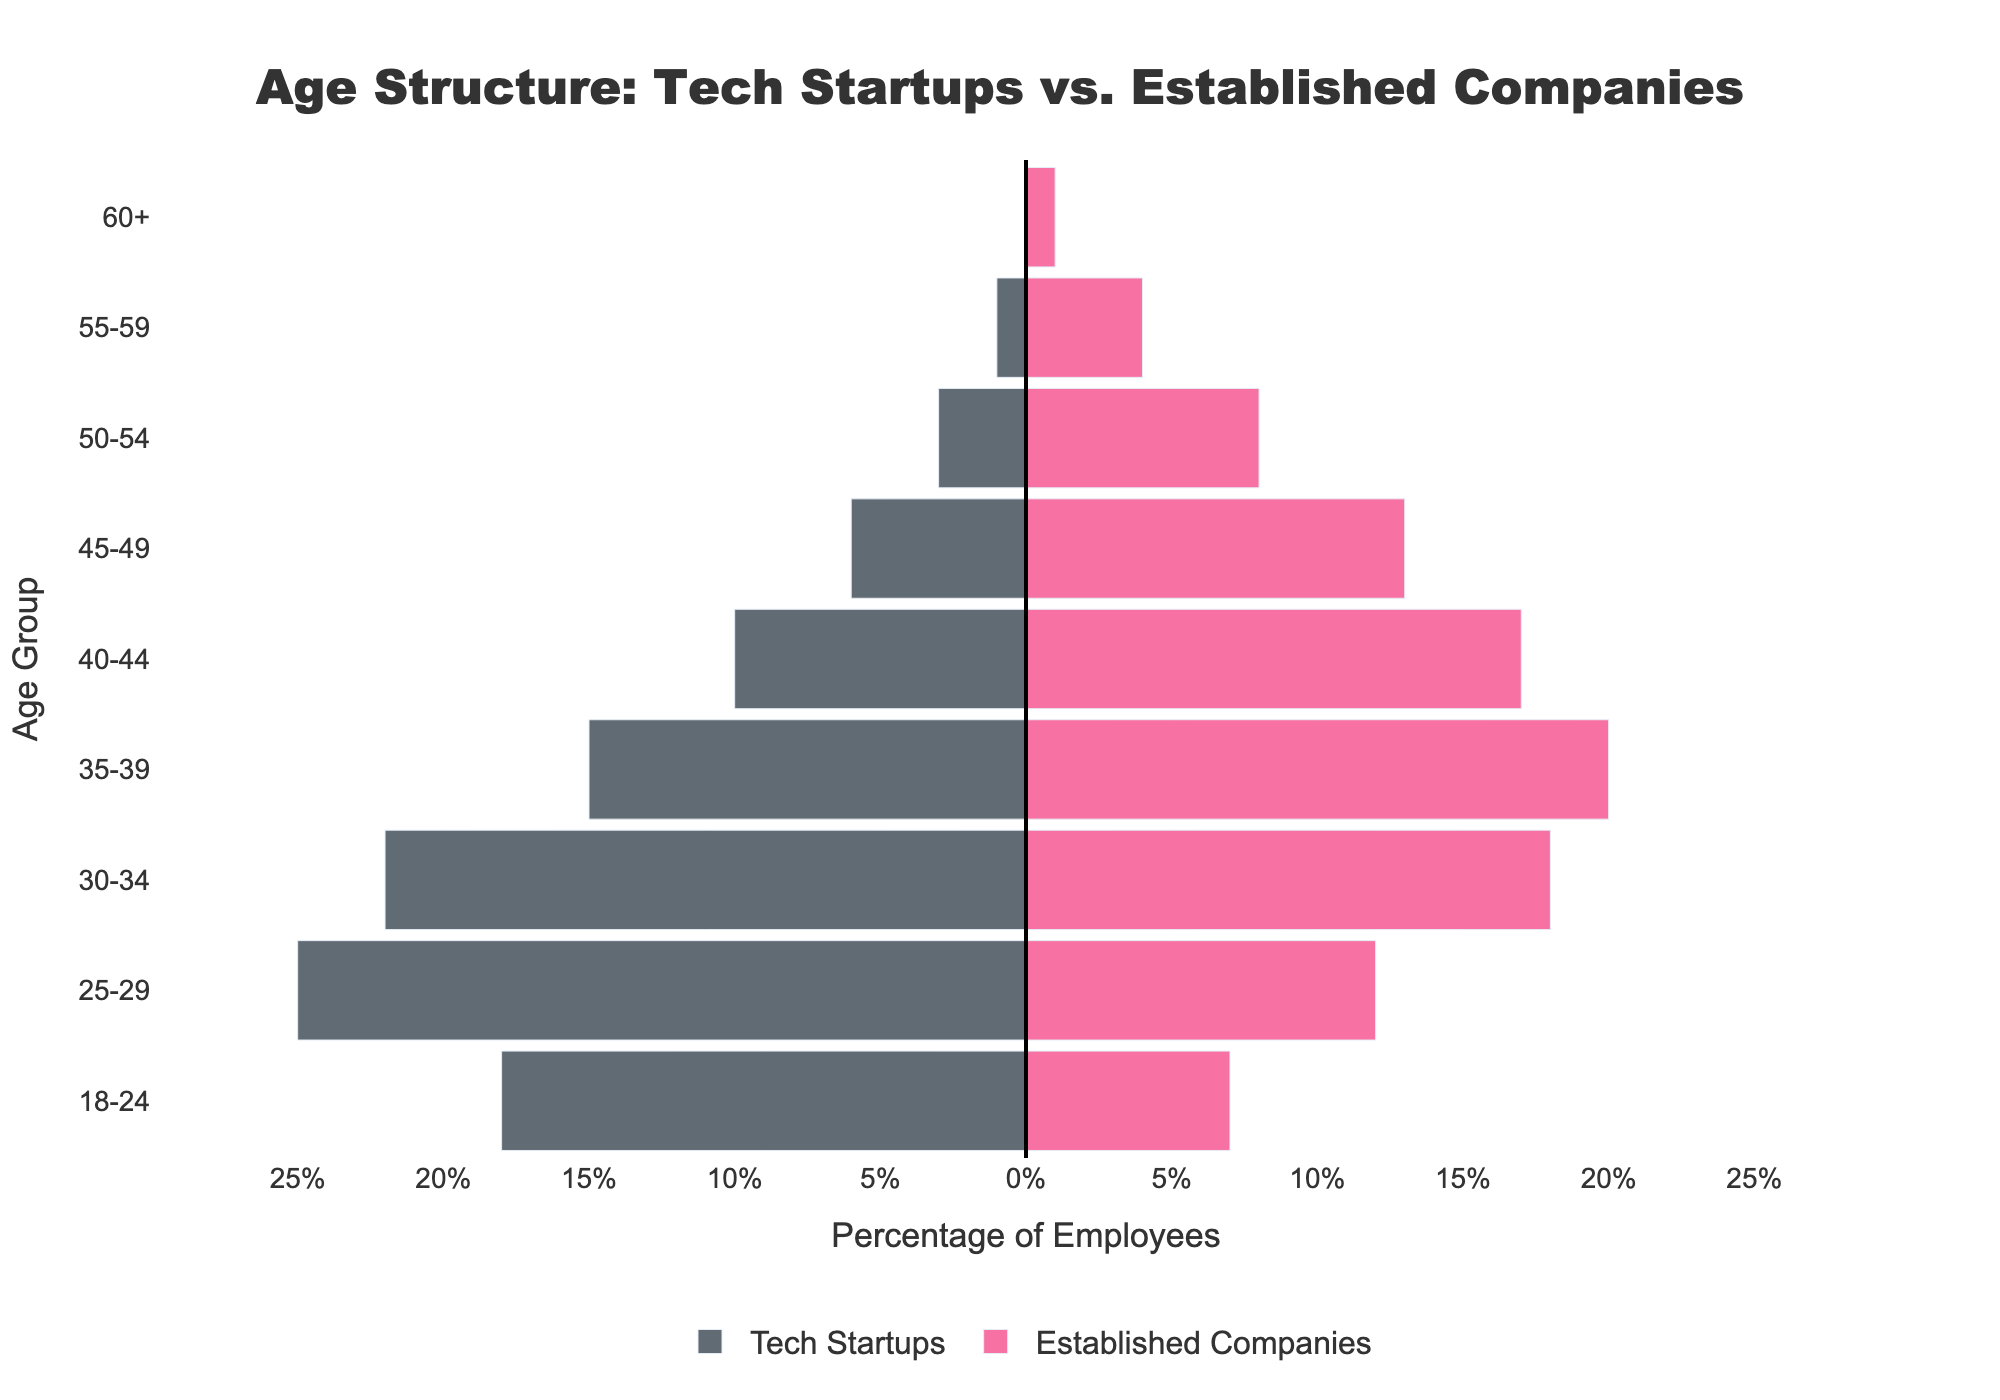What is the age group with the highest representation in tech startups? The bar representing the age group 25-29 for Tech Startups has the longest length in the left half of the pyramid plot.
Answer: 25-29 What is the age group with the highest representation in established companies? The bar representing the age group 35-39 for Established Companies has the longest length in the right half of the pyramid plot.
Answer: 35-39 How many total employees are there in the age group 40-44 across both tech startups and established companies? Add the counts for the age group 40-44 from both Tech Startups and Established Companies: 10 (Tech Startups) + 17 (Established Companies) = 27.
Answer: 27 Which age group has a higher percentage of employees in established companies compared to tech startups? Compare the bar lengths of each age group in Established Companies to Tech Startups; the age group 35-39 has a longer bar in Established Companies compared to Tech Startups.
Answer: 35-39 For the age group 30-34, how many more employees are there in tech startups compared to established companies? Subtract the number of employees in established companies from the number in tech startups for the age group 30-34: 22 (Tech Startups) - 18 (Established Companies) = 4.
Answer: 4 What is the combined total number of employees aged 60+ in both types of companies? Add the counts for the age group 60+ from Tech Startups and Established Companies: 0 (Tech Startups) + 1 (Established Companies) = 1.
Answer: 1 Does the age group 25-29 or 35-39 have a greater number of employees in tech startups? Compare the lengths of bars representing the age groups 25-29 and 35-39 in Tech Startups; 25-29 has 25 employees, while 35-39 has 15.
Answer: 25-29 Which age groups have zero employees in tech startups? Look at the bars on the Tech Startups' side of the pyramid plot; the age group 60+ has zero employees.
Answer: 60+ What is the age group with the lowest representation in established companies? The bar representing the age group 60+ has the shortest length on the right side of the pyramid plot.
Answer: 60+ 